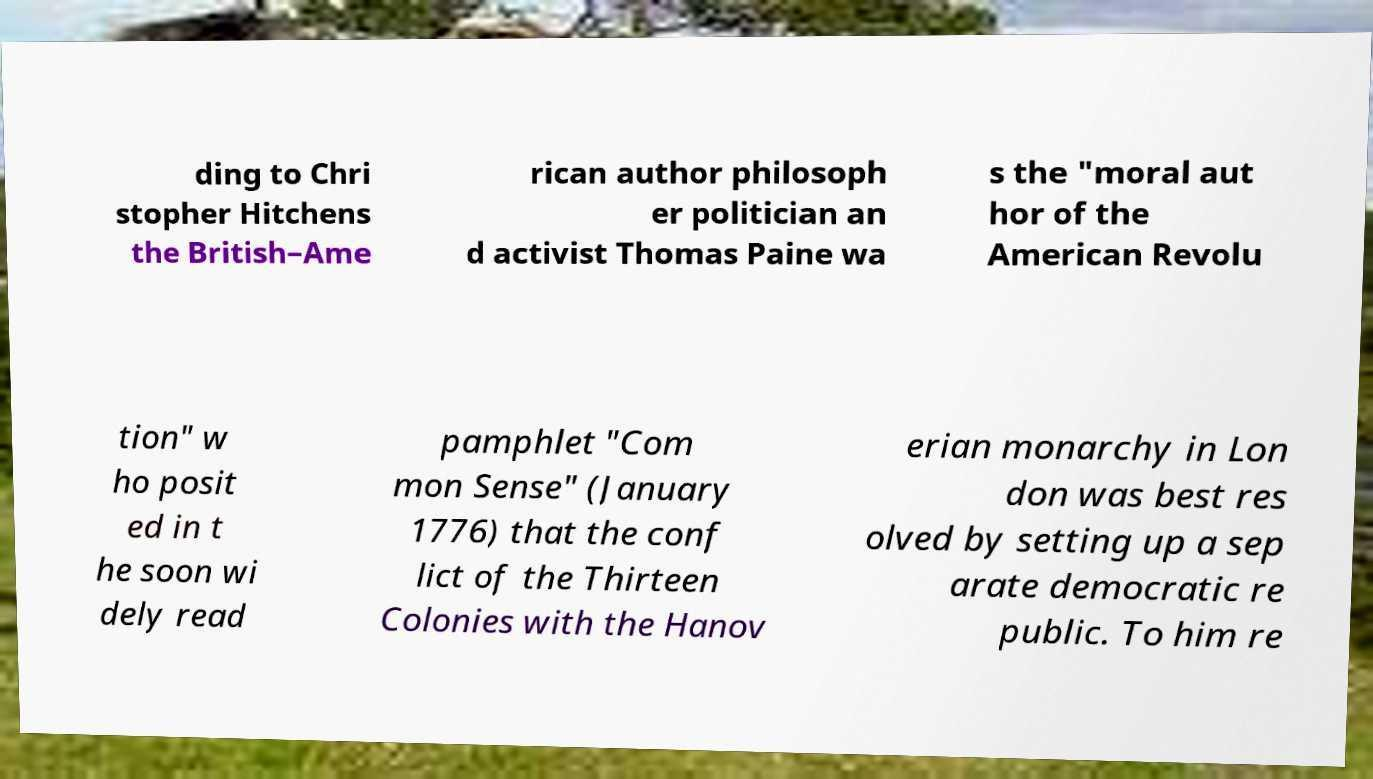I need the written content from this picture converted into text. Can you do that? ding to Chri stopher Hitchens the British–Ame rican author philosoph er politician an d activist Thomas Paine wa s the "moral aut hor of the American Revolu tion" w ho posit ed in t he soon wi dely read pamphlet "Com mon Sense" (January 1776) that the conf lict of the Thirteen Colonies with the Hanov erian monarchy in Lon don was best res olved by setting up a sep arate democratic re public. To him re 